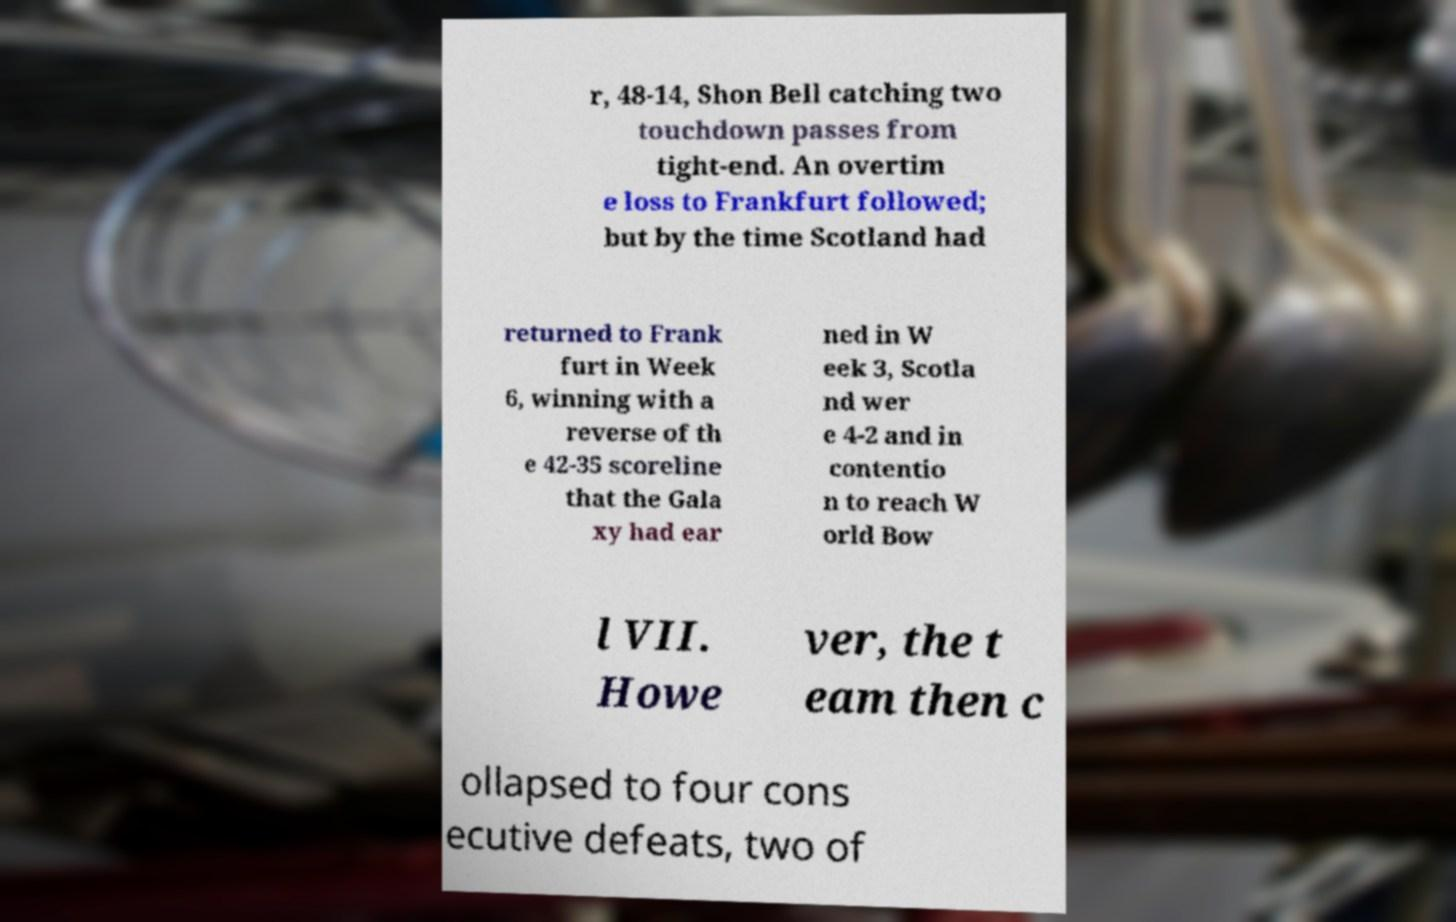What messages or text are displayed in this image? I need them in a readable, typed format. r, 48-14, Shon Bell catching two touchdown passes from tight-end. An overtim e loss to Frankfurt followed; but by the time Scotland had returned to Frank furt in Week 6, winning with a reverse of th e 42-35 scoreline that the Gala xy had ear ned in W eek 3, Scotla nd wer e 4-2 and in contentio n to reach W orld Bow l VII. Howe ver, the t eam then c ollapsed to four cons ecutive defeats, two of 